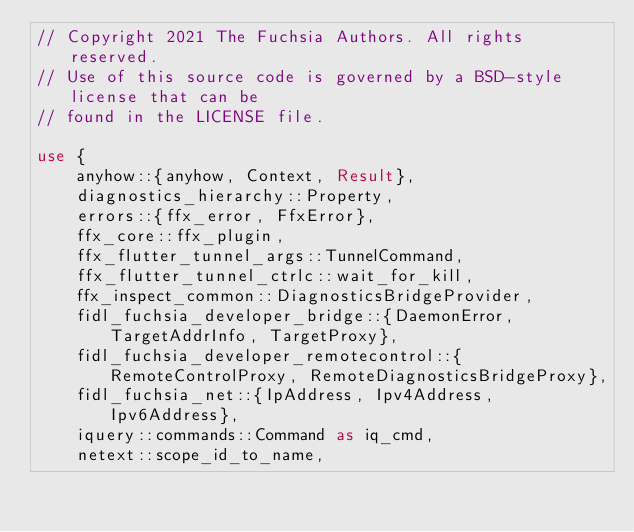<code> <loc_0><loc_0><loc_500><loc_500><_Rust_>// Copyright 2021 The Fuchsia Authors. All rights reserved.
// Use of this source code is governed by a BSD-style license that can be
// found in the LICENSE file.

use {
    anyhow::{anyhow, Context, Result},
    diagnostics_hierarchy::Property,
    errors::{ffx_error, FfxError},
    ffx_core::ffx_plugin,
    ffx_flutter_tunnel_args::TunnelCommand,
    ffx_flutter_tunnel_ctrlc::wait_for_kill,
    ffx_inspect_common::DiagnosticsBridgeProvider,
    fidl_fuchsia_developer_bridge::{DaemonError, TargetAddrInfo, TargetProxy},
    fidl_fuchsia_developer_remotecontrol::{RemoteControlProxy, RemoteDiagnosticsBridgeProxy},
    fidl_fuchsia_net::{IpAddress, Ipv4Address, Ipv6Address},
    iquery::commands::Command as iq_cmd,
    netext::scope_id_to_name,</code> 